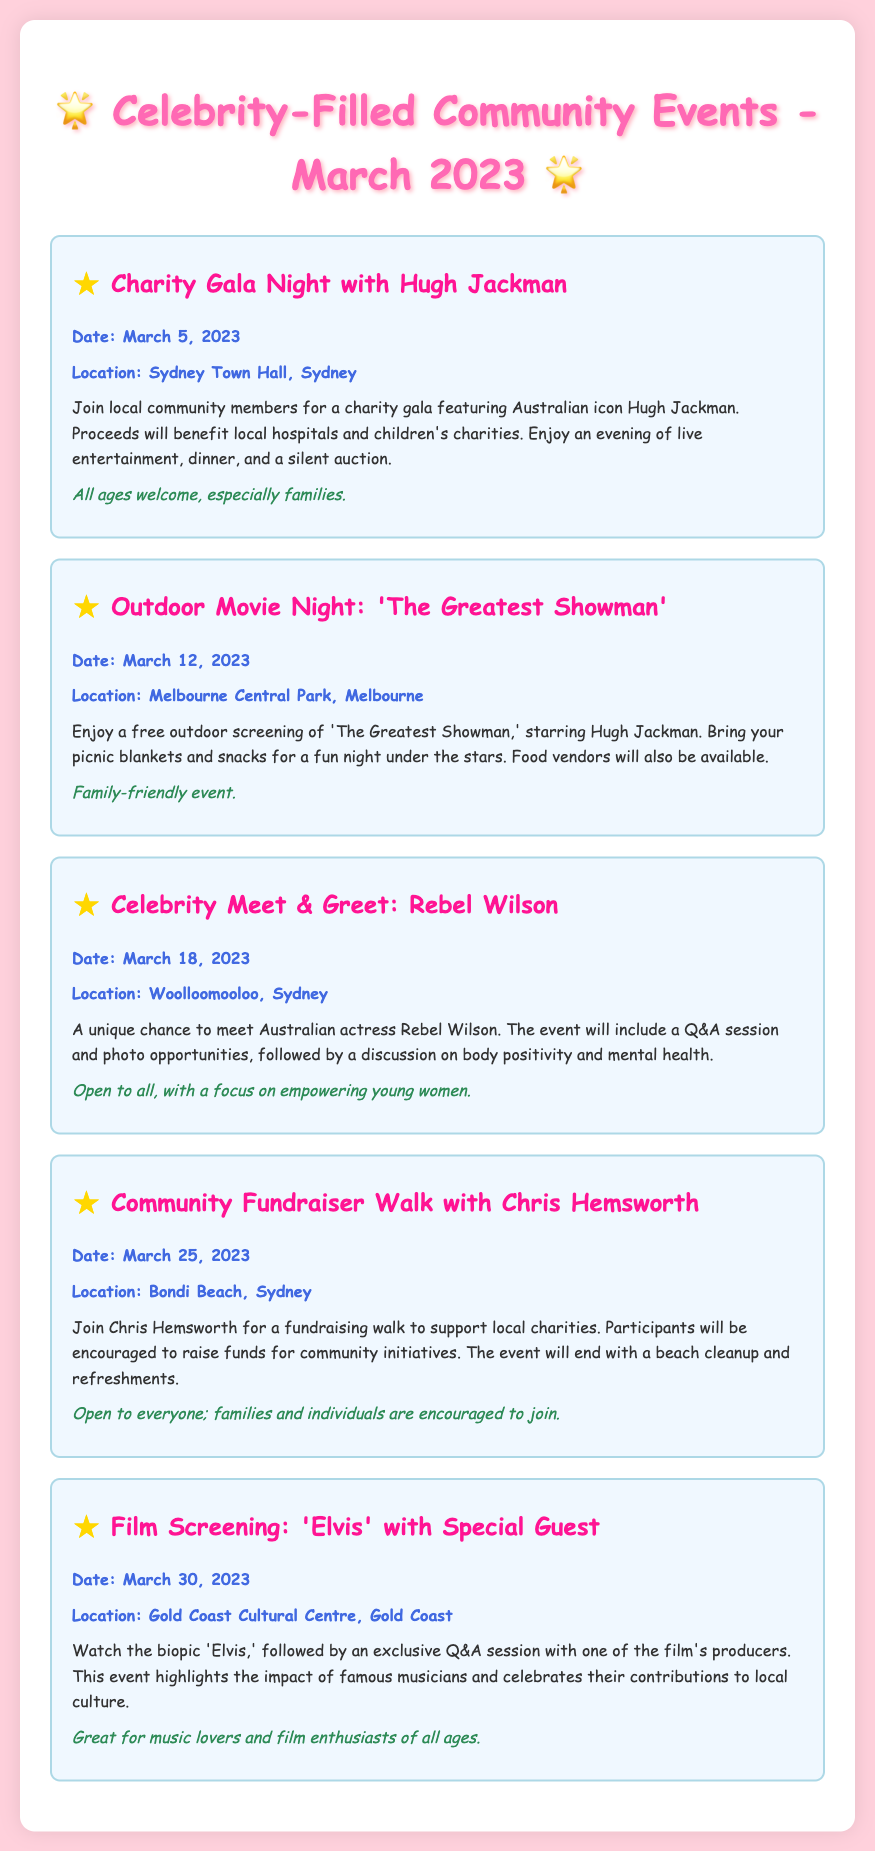What is the date of the Charity Gala Night? The document states that the Charity Gala Night is on March 5, 2023.
Answer: March 5, 2023 Who is hosting the Outdoor Movie Night? Hugh Jackman is the star of the movie 'The Greatest Showman' that will be screened at the Outdoor Movie Night.
Answer: Hugh Jackman Where is the Celebrity Meet & Greet with Rebel Wilson taking place? The location for the event is Woolloomooloo, Sydney.
Answer: Woolloomooloo, Sydney What is the main theme of the event featuring Rebel Wilson? The event includes a discussion on body positivity and mental health.
Answer: Body positivity and mental health How many days after the Movie Night is the Community Fundraiser Walk? The Community Fundraiser Walk is on March 25, and the Movie Night is on March 12, making it 13 days later.
Answer: 13 days What type of event is the screening of 'Elvis'? It is a film screening followed by an exclusive Q&A session.
Answer: Film screening Which celebrity is associated with the Community Fundraiser Walk? The community event is associated with Chris Hemsworth who will be attending.
Answer: Chris Hemsworth What is the expected audience for the Charity Gala Night? The event is open to all ages, especially families.
Answer: All ages, especially families 